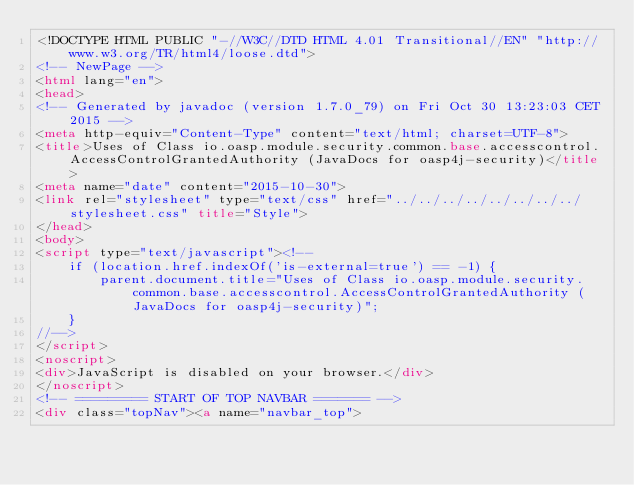<code> <loc_0><loc_0><loc_500><loc_500><_HTML_><!DOCTYPE HTML PUBLIC "-//W3C//DTD HTML 4.01 Transitional//EN" "http://www.w3.org/TR/html4/loose.dtd">
<!-- NewPage -->
<html lang="en">
<head>
<!-- Generated by javadoc (version 1.7.0_79) on Fri Oct 30 13:23:03 CET 2015 -->
<meta http-equiv="Content-Type" content="text/html; charset=UTF-8">
<title>Uses of Class io.oasp.module.security.common.base.accesscontrol.AccessControlGrantedAuthority (JavaDocs for oasp4j-security)</title>
<meta name="date" content="2015-10-30">
<link rel="stylesheet" type="text/css" href="../../../../../../../../stylesheet.css" title="Style">
</head>
<body>
<script type="text/javascript"><!--
    if (location.href.indexOf('is-external=true') == -1) {
        parent.document.title="Uses of Class io.oasp.module.security.common.base.accesscontrol.AccessControlGrantedAuthority (JavaDocs for oasp4j-security)";
    }
//-->
</script>
<noscript>
<div>JavaScript is disabled on your browser.</div>
</noscript>
<!-- ========= START OF TOP NAVBAR ======= -->
<div class="topNav"><a name="navbar_top"></code> 